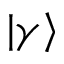<formula> <loc_0><loc_0><loc_500><loc_500>| \gamma \rangle</formula> 